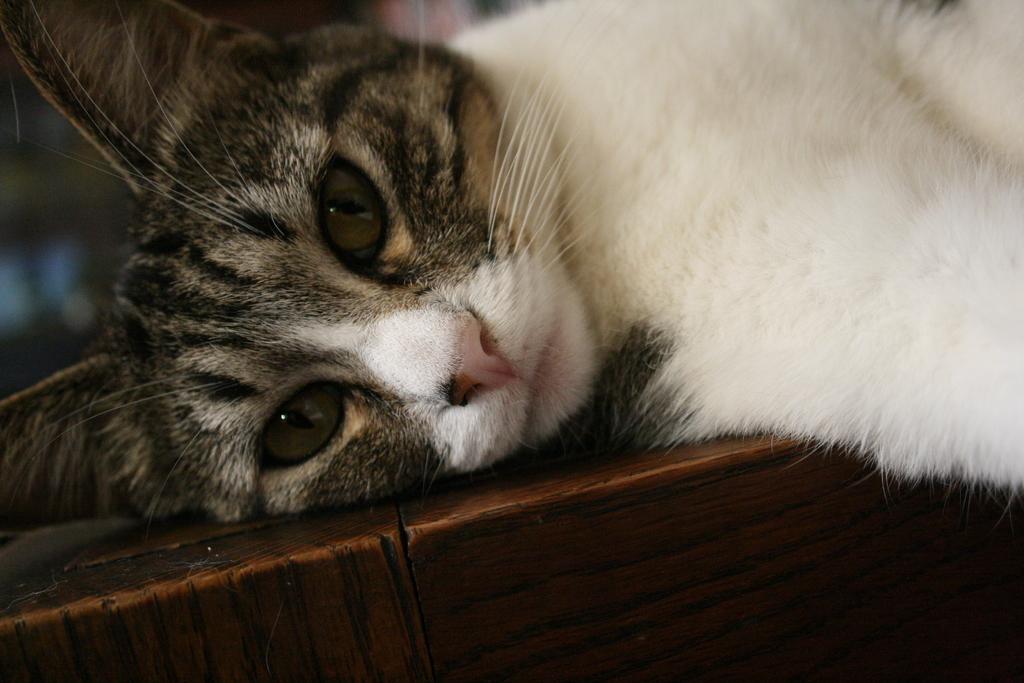Please provide a concise description of this image. Here in this picture we can see a cat lying over a place. 